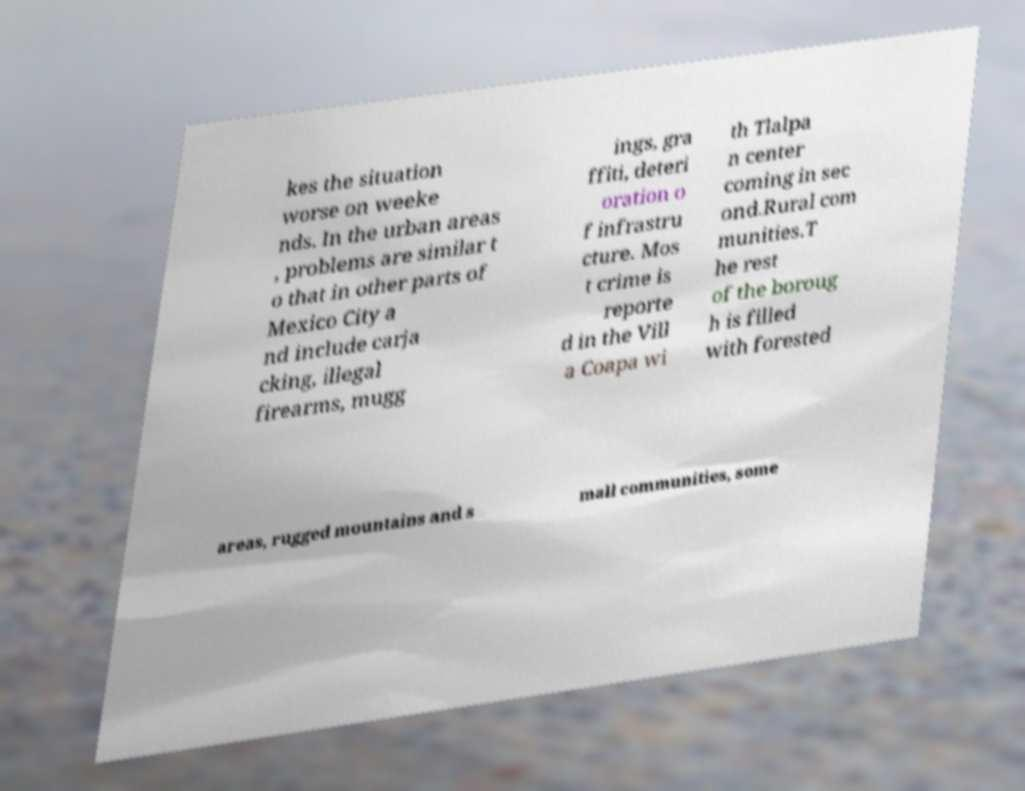Please read and relay the text visible in this image. What does it say? kes the situation worse on weeke nds. In the urban areas , problems are similar t o that in other parts of Mexico City a nd include carja cking, illegal firearms, mugg ings, gra ffiti, deteri oration o f infrastru cture. Mos t crime is reporte d in the Vill a Coapa wi th Tlalpa n center coming in sec ond.Rural com munities.T he rest of the boroug h is filled with forested areas, rugged mountains and s mall communities, some 